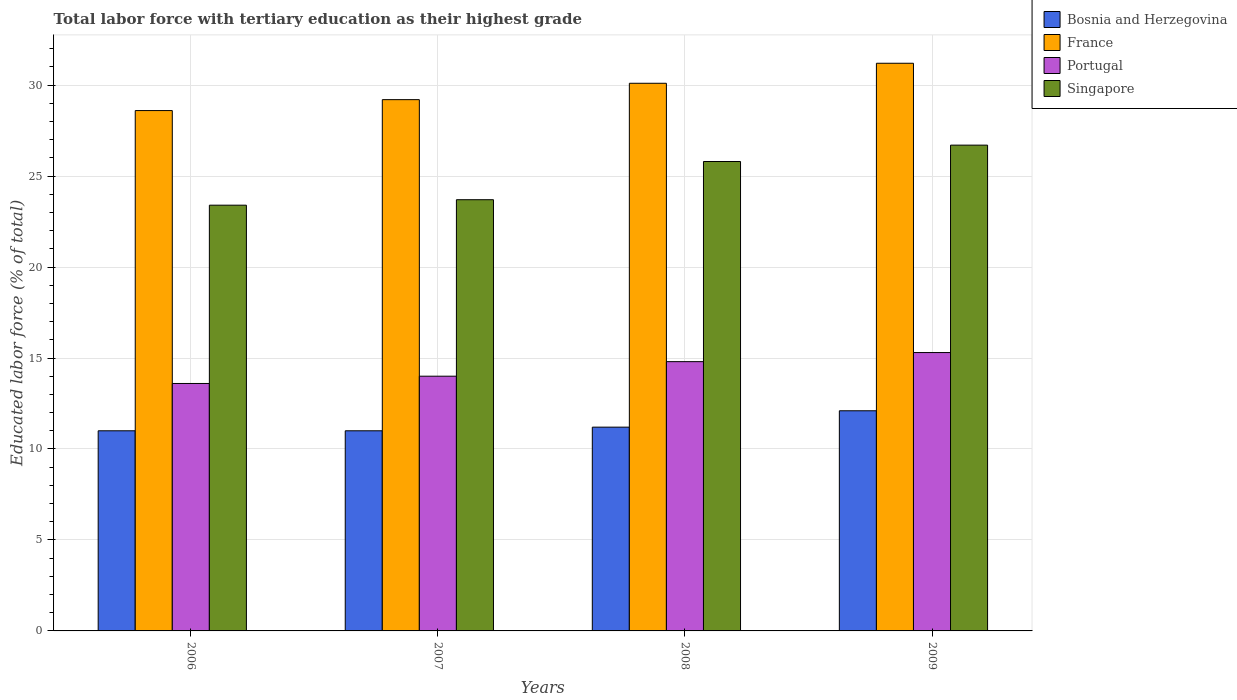How many different coloured bars are there?
Your answer should be very brief. 4. How many groups of bars are there?
Offer a terse response. 4. Are the number of bars per tick equal to the number of legend labels?
Provide a short and direct response. Yes. How many bars are there on the 4th tick from the left?
Your answer should be compact. 4. In how many cases, is the number of bars for a given year not equal to the number of legend labels?
Ensure brevity in your answer.  0. What is the percentage of male labor force with tertiary education in Singapore in 2006?
Keep it short and to the point. 23.4. Across all years, what is the maximum percentage of male labor force with tertiary education in Bosnia and Herzegovina?
Offer a terse response. 12.1. Across all years, what is the minimum percentage of male labor force with tertiary education in Portugal?
Provide a short and direct response. 13.6. In which year was the percentage of male labor force with tertiary education in France maximum?
Your answer should be very brief. 2009. What is the total percentage of male labor force with tertiary education in Singapore in the graph?
Offer a terse response. 99.6. What is the difference between the percentage of male labor force with tertiary education in Portugal in 2006 and that in 2009?
Your answer should be very brief. -1.7. What is the difference between the percentage of male labor force with tertiary education in Bosnia and Herzegovina in 2009 and the percentage of male labor force with tertiary education in Portugal in 2006?
Keep it short and to the point. -1.5. What is the average percentage of male labor force with tertiary education in Portugal per year?
Offer a very short reply. 14.43. In the year 2009, what is the difference between the percentage of male labor force with tertiary education in Singapore and percentage of male labor force with tertiary education in Bosnia and Herzegovina?
Give a very brief answer. 14.6. In how many years, is the percentage of male labor force with tertiary education in France greater than 18 %?
Ensure brevity in your answer.  4. What is the ratio of the percentage of male labor force with tertiary education in Singapore in 2008 to that in 2009?
Give a very brief answer. 0.97. What is the difference between the highest and the lowest percentage of male labor force with tertiary education in France?
Make the answer very short. 2.6. What does the 4th bar from the left in 2006 represents?
Keep it short and to the point. Singapore. What does the 1st bar from the right in 2006 represents?
Ensure brevity in your answer.  Singapore. Is it the case that in every year, the sum of the percentage of male labor force with tertiary education in France and percentage of male labor force with tertiary education in Portugal is greater than the percentage of male labor force with tertiary education in Bosnia and Herzegovina?
Give a very brief answer. Yes. How many bars are there?
Make the answer very short. 16. Are all the bars in the graph horizontal?
Provide a short and direct response. No. What is the difference between two consecutive major ticks on the Y-axis?
Your response must be concise. 5. Are the values on the major ticks of Y-axis written in scientific E-notation?
Offer a terse response. No. Does the graph contain grids?
Ensure brevity in your answer.  Yes. Where does the legend appear in the graph?
Your answer should be compact. Top right. How many legend labels are there?
Provide a succinct answer. 4. How are the legend labels stacked?
Provide a short and direct response. Vertical. What is the title of the graph?
Your answer should be very brief. Total labor force with tertiary education as their highest grade. What is the label or title of the Y-axis?
Your response must be concise. Educated labor force (% of total). What is the Educated labor force (% of total) of France in 2006?
Ensure brevity in your answer.  28.6. What is the Educated labor force (% of total) in Portugal in 2006?
Make the answer very short. 13.6. What is the Educated labor force (% of total) in Singapore in 2006?
Give a very brief answer. 23.4. What is the Educated labor force (% of total) in Bosnia and Herzegovina in 2007?
Provide a succinct answer. 11. What is the Educated labor force (% of total) of France in 2007?
Make the answer very short. 29.2. What is the Educated labor force (% of total) of Singapore in 2007?
Offer a very short reply. 23.7. What is the Educated labor force (% of total) in Bosnia and Herzegovina in 2008?
Keep it short and to the point. 11.2. What is the Educated labor force (% of total) in France in 2008?
Keep it short and to the point. 30.1. What is the Educated labor force (% of total) in Portugal in 2008?
Give a very brief answer. 14.8. What is the Educated labor force (% of total) in Singapore in 2008?
Give a very brief answer. 25.8. What is the Educated labor force (% of total) of Bosnia and Herzegovina in 2009?
Ensure brevity in your answer.  12.1. What is the Educated labor force (% of total) in France in 2009?
Ensure brevity in your answer.  31.2. What is the Educated labor force (% of total) of Portugal in 2009?
Make the answer very short. 15.3. What is the Educated labor force (% of total) of Singapore in 2009?
Give a very brief answer. 26.7. Across all years, what is the maximum Educated labor force (% of total) of Bosnia and Herzegovina?
Give a very brief answer. 12.1. Across all years, what is the maximum Educated labor force (% of total) of France?
Your response must be concise. 31.2. Across all years, what is the maximum Educated labor force (% of total) in Portugal?
Give a very brief answer. 15.3. Across all years, what is the maximum Educated labor force (% of total) in Singapore?
Keep it short and to the point. 26.7. Across all years, what is the minimum Educated labor force (% of total) in Bosnia and Herzegovina?
Your response must be concise. 11. Across all years, what is the minimum Educated labor force (% of total) in France?
Ensure brevity in your answer.  28.6. Across all years, what is the minimum Educated labor force (% of total) in Portugal?
Your answer should be very brief. 13.6. Across all years, what is the minimum Educated labor force (% of total) in Singapore?
Keep it short and to the point. 23.4. What is the total Educated labor force (% of total) in Bosnia and Herzegovina in the graph?
Offer a very short reply. 45.3. What is the total Educated labor force (% of total) of France in the graph?
Your answer should be compact. 119.1. What is the total Educated labor force (% of total) of Portugal in the graph?
Keep it short and to the point. 57.7. What is the total Educated labor force (% of total) in Singapore in the graph?
Your answer should be very brief. 99.6. What is the difference between the Educated labor force (% of total) of Bosnia and Herzegovina in 2006 and that in 2007?
Provide a succinct answer. 0. What is the difference between the Educated labor force (% of total) in Portugal in 2006 and that in 2007?
Offer a very short reply. -0.4. What is the difference between the Educated labor force (% of total) of Singapore in 2006 and that in 2007?
Offer a very short reply. -0.3. What is the difference between the Educated labor force (% of total) in Portugal in 2006 and that in 2008?
Offer a very short reply. -1.2. What is the difference between the Educated labor force (% of total) of Portugal in 2006 and that in 2009?
Give a very brief answer. -1.7. What is the difference between the Educated labor force (% of total) of Singapore in 2006 and that in 2009?
Give a very brief answer. -3.3. What is the difference between the Educated labor force (% of total) of France in 2007 and that in 2008?
Give a very brief answer. -0.9. What is the difference between the Educated labor force (% of total) in Portugal in 2007 and that in 2008?
Offer a very short reply. -0.8. What is the difference between the Educated labor force (% of total) of Singapore in 2007 and that in 2008?
Make the answer very short. -2.1. What is the difference between the Educated labor force (% of total) in Bosnia and Herzegovina in 2007 and that in 2009?
Keep it short and to the point. -1.1. What is the difference between the Educated labor force (% of total) in Portugal in 2007 and that in 2009?
Your answer should be compact. -1.3. What is the difference between the Educated labor force (% of total) in Singapore in 2007 and that in 2009?
Keep it short and to the point. -3. What is the difference between the Educated labor force (% of total) in France in 2008 and that in 2009?
Your response must be concise. -1.1. What is the difference between the Educated labor force (% of total) in Singapore in 2008 and that in 2009?
Keep it short and to the point. -0.9. What is the difference between the Educated labor force (% of total) in Bosnia and Herzegovina in 2006 and the Educated labor force (% of total) in France in 2007?
Offer a terse response. -18.2. What is the difference between the Educated labor force (% of total) in France in 2006 and the Educated labor force (% of total) in Portugal in 2007?
Provide a short and direct response. 14.6. What is the difference between the Educated labor force (% of total) in Bosnia and Herzegovina in 2006 and the Educated labor force (% of total) in France in 2008?
Give a very brief answer. -19.1. What is the difference between the Educated labor force (% of total) of Bosnia and Herzegovina in 2006 and the Educated labor force (% of total) of Portugal in 2008?
Ensure brevity in your answer.  -3.8. What is the difference between the Educated labor force (% of total) of Bosnia and Herzegovina in 2006 and the Educated labor force (% of total) of Singapore in 2008?
Offer a terse response. -14.8. What is the difference between the Educated labor force (% of total) in Bosnia and Herzegovina in 2006 and the Educated labor force (% of total) in France in 2009?
Offer a terse response. -20.2. What is the difference between the Educated labor force (% of total) of Bosnia and Herzegovina in 2006 and the Educated labor force (% of total) of Portugal in 2009?
Ensure brevity in your answer.  -4.3. What is the difference between the Educated labor force (% of total) of Bosnia and Herzegovina in 2006 and the Educated labor force (% of total) of Singapore in 2009?
Provide a short and direct response. -15.7. What is the difference between the Educated labor force (% of total) in Portugal in 2006 and the Educated labor force (% of total) in Singapore in 2009?
Offer a very short reply. -13.1. What is the difference between the Educated labor force (% of total) in Bosnia and Herzegovina in 2007 and the Educated labor force (% of total) in France in 2008?
Keep it short and to the point. -19.1. What is the difference between the Educated labor force (% of total) in Bosnia and Herzegovina in 2007 and the Educated labor force (% of total) in Portugal in 2008?
Give a very brief answer. -3.8. What is the difference between the Educated labor force (% of total) of Bosnia and Herzegovina in 2007 and the Educated labor force (% of total) of Singapore in 2008?
Your answer should be compact. -14.8. What is the difference between the Educated labor force (% of total) in Portugal in 2007 and the Educated labor force (% of total) in Singapore in 2008?
Keep it short and to the point. -11.8. What is the difference between the Educated labor force (% of total) of Bosnia and Herzegovina in 2007 and the Educated labor force (% of total) of France in 2009?
Give a very brief answer. -20.2. What is the difference between the Educated labor force (% of total) of Bosnia and Herzegovina in 2007 and the Educated labor force (% of total) of Singapore in 2009?
Your response must be concise. -15.7. What is the difference between the Educated labor force (% of total) of France in 2007 and the Educated labor force (% of total) of Portugal in 2009?
Your response must be concise. 13.9. What is the difference between the Educated labor force (% of total) in Portugal in 2007 and the Educated labor force (% of total) in Singapore in 2009?
Offer a very short reply. -12.7. What is the difference between the Educated labor force (% of total) of Bosnia and Herzegovina in 2008 and the Educated labor force (% of total) of France in 2009?
Offer a very short reply. -20. What is the difference between the Educated labor force (% of total) in Bosnia and Herzegovina in 2008 and the Educated labor force (% of total) in Portugal in 2009?
Provide a short and direct response. -4.1. What is the difference between the Educated labor force (% of total) in Bosnia and Herzegovina in 2008 and the Educated labor force (% of total) in Singapore in 2009?
Your answer should be compact. -15.5. What is the difference between the Educated labor force (% of total) in France in 2008 and the Educated labor force (% of total) in Portugal in 2009?
Your response must be concise. 14.8. What is the average Educated labor force (% of total) in Bosnia and Herzegovina per year?
Your answer should be very brief. 11.32. What is the average Educated labor force (% of total) in France per year?
Offer a very short reply. 29.77. What is the average Educated labor force (% of total) of Portugal per year?
Keep it short and to the point. 14.43. What is the average Educated labor force (% of total) in Singapore per year?
Keep it short and to the point. 24.9. In the year 2006, what is the difference between the Educated labor force (% of total) in Bosnia and Herzegovina and Educated labor force (% of total) in France?
Your answer should be very brief. -17.6. In the year 2006, what is the difference between the Educated labor force (% of total) in Bosnia and Herzegovina and Educated labor force (% of total) in Portugal?
Your answer should be very brief. -2.6. In the year 2006, what is the difference between the Educated labor force (% of total) in Bosnia and Herzegovina and Educated labor force (% of total) in Singapore?
Keep it short and to the point. -12.4. In the year 2006, what is the difference between the Educated labor force (% of total) of France and Educated labor force (% of total) of Portugal?
Offer a very short reply. 15. In the year 2006, what is the difference between the Educated labor force (% of total) of France and Educated labor force (% of total) of Singapore?
Keep it short and to the point. 5.2. In the year 2006, what is the difference between the Educated labor force (% of total) in Portugal and Educated labor force (% of total) in Singapore?
Your answer should be very brief. -9.8. In the year 2007, what is the difference between the Educated labor force (% of total) of Bosnia and Herzegovina and Educated labor force (% of total) of France?
Make the answer very short. -18.2. In the year 2007, what is the difference between the Educated labor force (% of total) in Bosnia and Herzegovina and Educated labor force (% of total) in Singapore?
Ensure brevity in your answer.  -12.7. In the year 2007, what is the difference between the Educated labor force (% of total) of Portugal and Educated labor force (% of total) of Singapore?
Make the answer very short. -9.7. In the year 2008, what is the difference between the Educated labor force (% of total) in Bosnia and Herzegovina and Educated labor force (% of total) in France?
Offer a very short reply. -18.9. In the year 2008, what is the difference between the Educated labor force (% of total) in Bosnia and Herzegovina and Educated labor force (% of total) in Singapore?
Keep it short and to the point. -14.6. In the year 2008, what is the difference between the Educated labor force (% of total) in France and Educated labor force (% of total) in Singapore?
Offer a very short reply. 4.3. In the year 2009, what is the difference between the Educated labor force (% of total) in Bosnia and Herzegovina and Educated labor force (% of total) in France?
Your response must be concise. -19.1. In the year 2009, what is the difference between the Educated labor force (% of total) of Bosnia and Herzegovina and Educated labor force (% of total) of Singapore?
Ensure brevity in your answer.  -14.6. In the year 2009, what is the difference between the Educated labor force (% of total) of France and Educated labor force (% of total) of Portugal?
Provide a short and direct response. 15.9. In the year 2009, what is the difference between the Educated labor force (% of total) in France and Educated labor force (% of total) in Singapore?
Your answer should be very brief. 4.5. In the year 2009, what is the difference between the Educated labor force (% of total) in Portugal and Educated labor force (% of total) in Singapore?
Keep it short and to the point. -11.4. What is the ratio of the Educated labor force (% of total) of France in 2006 to that in 2007?
Give a very brief answer. 0.98. What is the ratio of the Educated labor force (% of total) in Portugal in 2006 to that in 2007?
Make the answer very short. 0.97. What is the ratio of the Educated labor force (% of total) in Singapore in 2006 to that in 2007?
Your answer should be very brief. 0.99. What is the ratio of the Educated labor force (% of total) in Bosnia and Herzegovina in 2006 to that in 2008?
Your answer should be compact. 0.98. What is the ratio of the Educated labor force (% of total) of France in 2006 to that in 2008?
Give a very brief answer. 0.95. What is the ratio of the Educated labor force (% of total) in Portugal in 2006 to that in 2008?
Give a very brief answer. 0.92. What is the ratio of the Educated labor force (% of total) of Singapore in 2006 to that in 2008?
Provide a succinct answer. 0.91. What is the ratio of the Educated labor force (% of total) in Bosnia and Herzegovina in 2006 to that in 2009?
Your answer should be very brief. 0.91. What is the ratio of the Educated labor force (% of total) in Portugal in 2006 to that in 2009?
Ensure brevity in your answer.  0.89. What is the ratio of the Educated labor force (% of total) in Singapore in 2006 to that in 2009?
Your response must be concise. 0.88. What is the ratio of the Educated labor force (% of total) of Bosnia and Herzegovina in 2007 to that in 2008?
Give a very brief answer. 0.98. What is the ratio of the Educated labor force (% of total) of France in 2007 to that in 2008?
Your response must be concise. 0.97. What is the ratio of the Educated labor force (% of total) of Portugal in 2007 to that in 2008?
Offer a terse response. 0.95. What is the ratio of the Educated labor force (% of total) of Singapore in 2007 to that in 2008?
Make the answer very short. 0.92. What is the ratio of the Educated labor force (% of total) of Bosnia and Herzegovina in 2007 to that in 2009?
Your answer should be very brief. 0.91. What is the ratio of the Educated labor force (% of total) of France in 2007 to that in 2009?
Give a very brief answer. 0.94. What is the ratio of the Educated labor force (% of total) of Portugal in 2007 to that in 2009?
Make the answer very short. 0.92. What is the ratio of the Educated labor force (% of total) of Singapore in 2007 to that in 2009?
Keep it short and to the point. 0.89. What is the ratio of the Educated labor force (% of total) in Bosnia and Herzegovina in 2008 to that in 2009?
Your response must be concise. 0.93. What is the ratio of the Educated labor force (% of total) in France in 2008 to that in 2009?
Your response must be concise. 0.96. What is the ratio of the Educated labor force (% of total) of Portugal in 2008 to that in 2009?
Your answer should be compact. 0.97. What is the ratio of the Educated labor force (% of total) of Singapore in 2008 to that in 2009?
Your answer should be very brief. 0.97. What is the difference between the highest and the second highest Educated labor force (% of total) in Bosnia and Herzegovina?
Offer a very short reply. 0.9. What is the difference between the highest and the second highest Educated labor force (% of total) in Portugal?
Give a very brief answer. 0.5. What is the difference between the highest and the lowest Educated labor force (% of total) in France?
Provide a short and direct response. 2.6. 